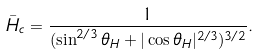<formula> <loc_0><loc_0><loc_500><loc_500>\bar { H } _ { c } = \frac { 1 } { ( \sin ^ { 2 / 3 } \theta _ { H } + | \cos \theta _ { H } | ^ { 2 / 3 } ) ^ { 3 / 2 } } .</formula> 